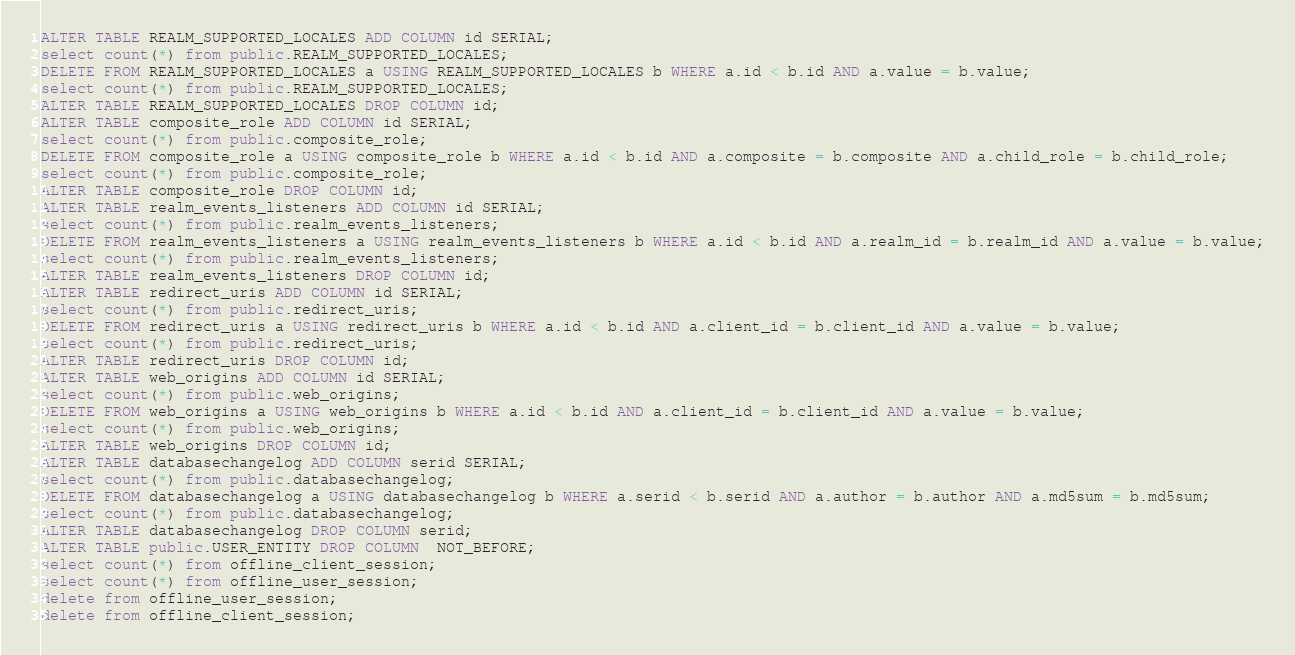Convert code to text. <code><loc_0><loc_0><loc_500><loc_500><_SQL_>ALTER TABLE REALM_SUPPORTED_LOCALES ADD COLUMN id SERIAL;
select count(*) from public.REALM_SUPPORTED_LOCALES;
DELETE FROM REALM_SUPPORTED_LOCALES a USING REALM_SUPPORTED_LOCALES b WHERE a.id < b.id AND a.value = b.value;
select count(*) from public.REALM_SUPPORTED_LOCALES;
ALTER TABLE REALM_SUPPORTED_LOCALES DROP COLUMN id;
ALTER TABLE composite_role ADD COLUMN id SERIAL;
select count(*) from public.composite_role;
DELETE FROM composite_role a USING composite_role b WHERE a.id < b.id AND a.composite = b.composite AND a.child_role = b.child_role;
select count(*) from public.composite_role;
ALTER TABLE composite_role DROP COLUMN id;
ALTER TABLE realm_events_listeners ADD COLUMN id SERIAL;
select count(*) from public.realm_events_listeners;
DELETE FROM realm_events_listeners a USING realm_events_listeners b WHERE a.id < b.id AND a.realm_id = b.realm_id AND a.value = b.value;
select count(*) from public.realm_events_listeners;
ALTER TABLE realm_events_listeners DROP COLUMN id;
ALTER TABLE redirect_uris ADD COLUMN id SERIAL;
select count(*) from public.redirect_uris;
DELETE FROM redirect_uris a USING redirect_uris b WHERE a.id < b.id AND a.client_id = b.client_id AND a.value = b.value;
select count(*) from public.redirect_uris;
ALTER TABLE redirect_uris DROP COLUMN id;
ALTER TABLE web_origins ADD COLUMN id SERIAL;
select count(*) from public.web_origins;
DELETE FROM web_origins a USING web_origins b WHERE a.id < b.id AND a.client_id = b.client_id AND a.value = b.value;
select count(*) from public.web_origins;
ALTER TABLE web_origins DROP COLUMN id;
ALTER TABLE databasechangelog ADD COLUMN serid SERIAL;
select count(*) from public.databasechangelog;
DELETE FROM databasechangelog a USING databasechangelog b WHERE a.serid < b.serid AND a.author = b.author AND a.md5sum = b.md5sum;
select count(*) from public.databasechangelog;
ALTER TABLE databasechangelog DROP COLUMN serid;
ALTER TABLE public.USER_ENTITY DROP COLUMN  NOT_BEFORE;
select count(*) from offline_client_session;
select count(*) from offline_user_session;
delete from offline_user_session;
delete from offline_client_session;
</code> 